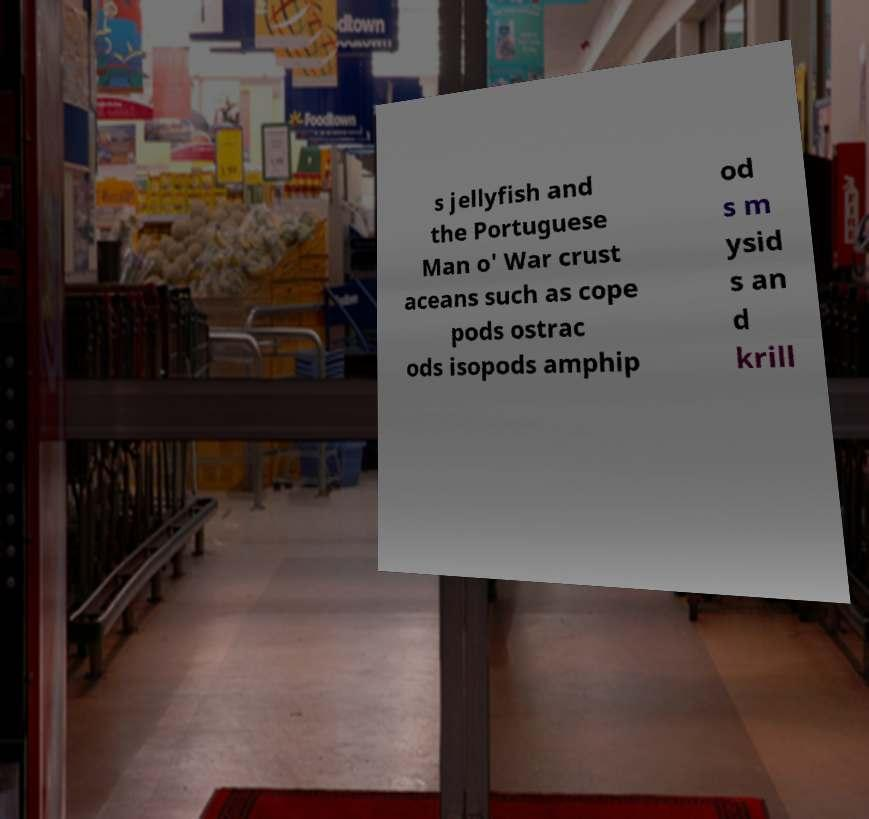Can you accurately transcribe the text from the provided image for me? s jellyfish and the Portuguese Man o' War crust aceans such as cope pods ostrac ods isopods amphip od s m ysid s an d krill 